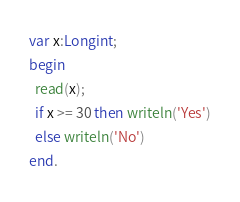Convert code to text. <code><loc_0><loc_0><loc_500><loc_500><_Pascal_>var x:Longint;
begin
  read(x);
  if x >= 30 then writeln('Yes')
  else writeln('No')
end.</code> 